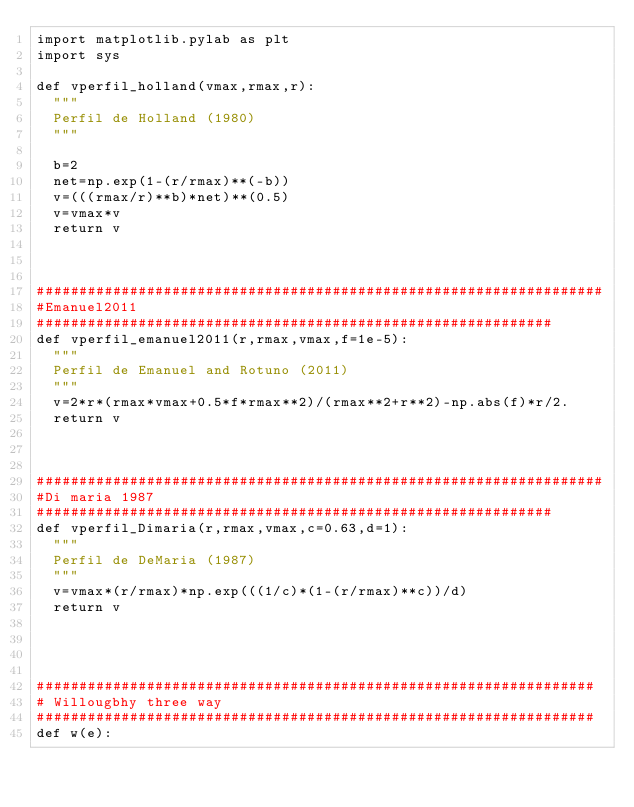<code> <loc_0><loc_0><loc_500><loc_500><_Python_>import matplotlib.pylab as plt
import sys

def vperfil_holland(vmax,rmax,r):
	"""
	Perfil de Holland (1980)
	"""

	b=2
	net=np.exp(1-(r/rmax)**(-b))
	v=(((rmax/r)**b)*net)**(0.5)
	v=vmax*v
	return v



###################################################################
#Emanuel2011
#############################################################
def vperfil_emanuel2011(r,rmax,vmax,f=1e-5):
	"""
	Perfil de Emanuel and Rotuno (2011)
	"""
	v=2*r*(rmax*vmax+0.5*f*rmax**2)/(rmax**2+r**2)-np.abs(f)*r/2.
	return v



###################################################################
#Di maria 1987
#############################################################
def vperfil_Dimaria(r,rmax,vmax,c=0.63,d=1):
	"""
	Perfil de DeMaria (1987)
	"""
	v=vmax*(r/rmax)*np.exp(((1/c)*(1-(r/rmax)**c))/d)
	return v




##################################################################
# Willougbhy three way
##################################################################
def w(e):</code> 